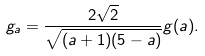<formula> <loc_0><loc_0><loc_500><loc_500>g _ { a } = \frac { 2 \sqrt { 2 } } { \sqrt { ( a + 1 ) ( 5 - a ) } } g ( a ) .</formula> 